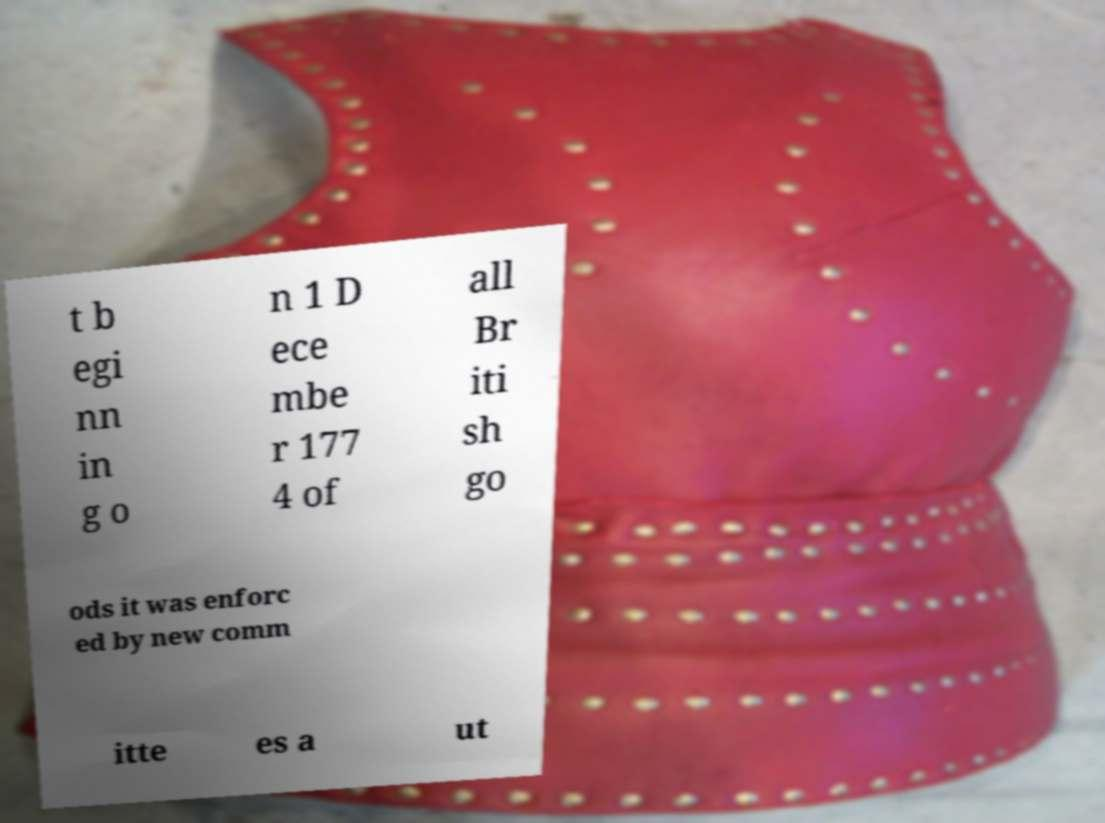I need the written content from this picture converted into text. Can you do that? t b egi nn in g o n 1 D ece mbe r 177 4 of all Br iti sh go ods it was enforc ed by new comm itte es a ut 